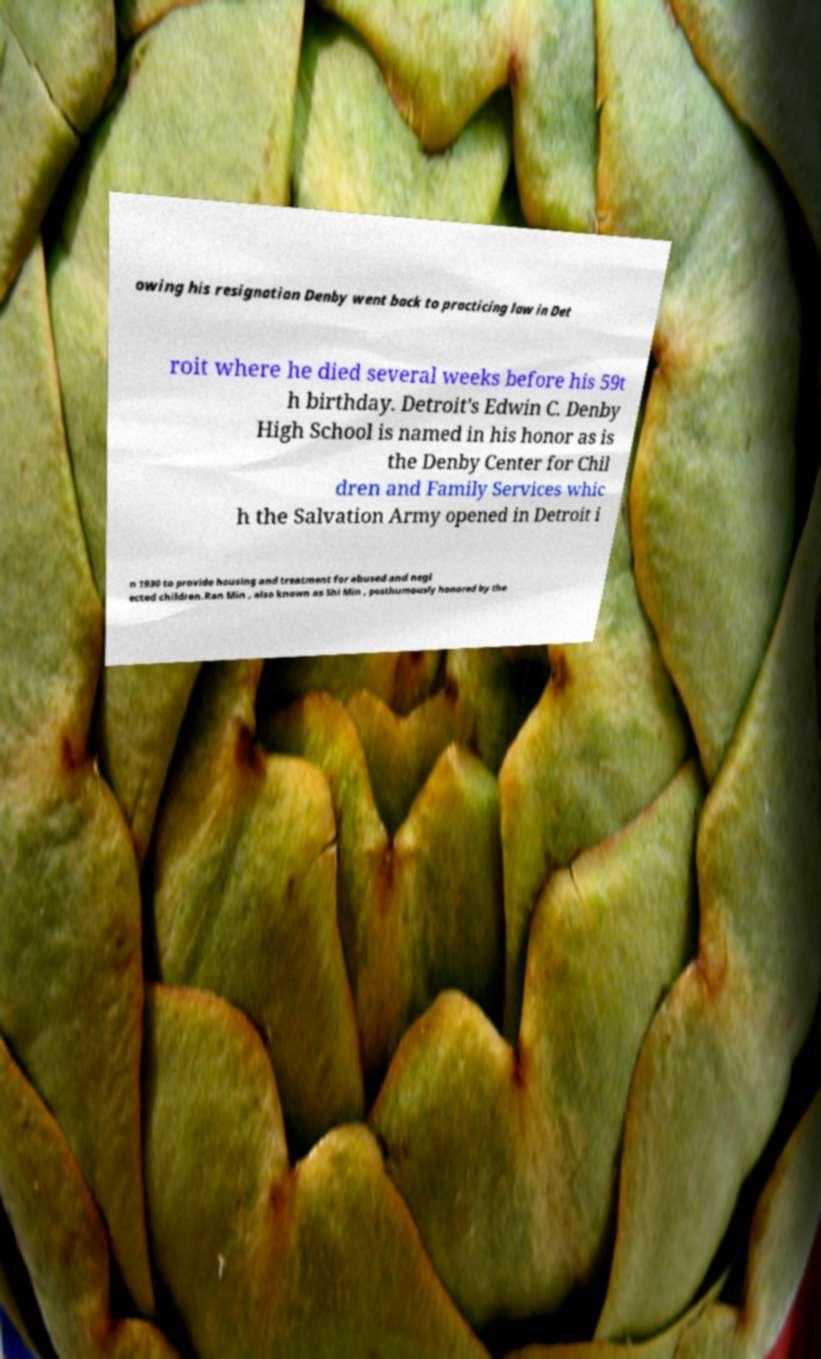Please identify and transcribe the text found in this image. owing his resignation Denby went back to practicing law in Det roit where he died several weeks before his 59t h birthday. Detroit's Edwin C. Denby High School is named in his honor as is the Denby Center for Chil dren and Family Services whic h the Salvation Army opened in Detroit i n 1930 to provide housing and treatment for abused and negl ected children.Ran Min , also known as Shi Min , posthumously honored by the 